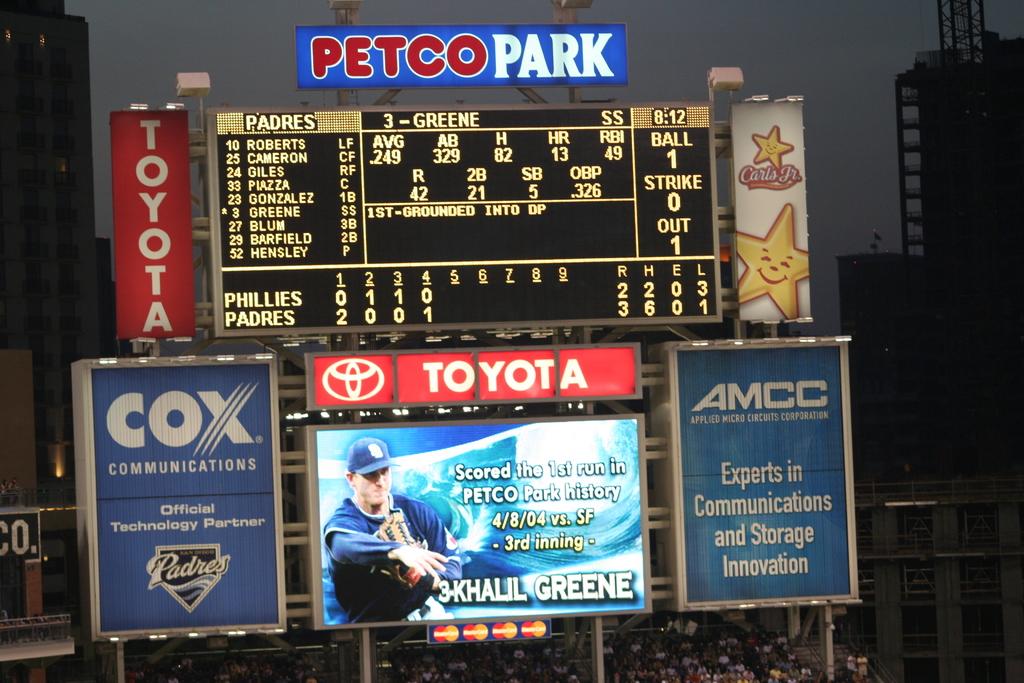What kind of advert is this?
Give a very brief answer. Toyota. What is the name of the t.v. service provider in blue?
Make the answer very short. Cox. 